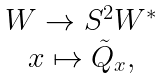Convert formula to latex. <formula><loc_0><loc_0><loc_500><loc_500>\begin{array} { c c } W \rightarrow S ^ { 2 } W ^ { * } \\ x \mapsto \tilde { Q } _ { x } , \end{array}</formula> 